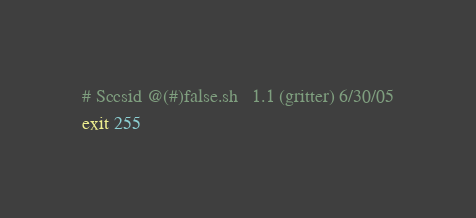<code> <loc_0><loc_0><loc_500><loc_500><_Bash_># Sccsid @(#)false.sh	1.1 (gritter) 6/30/05
exit 255
</code> 